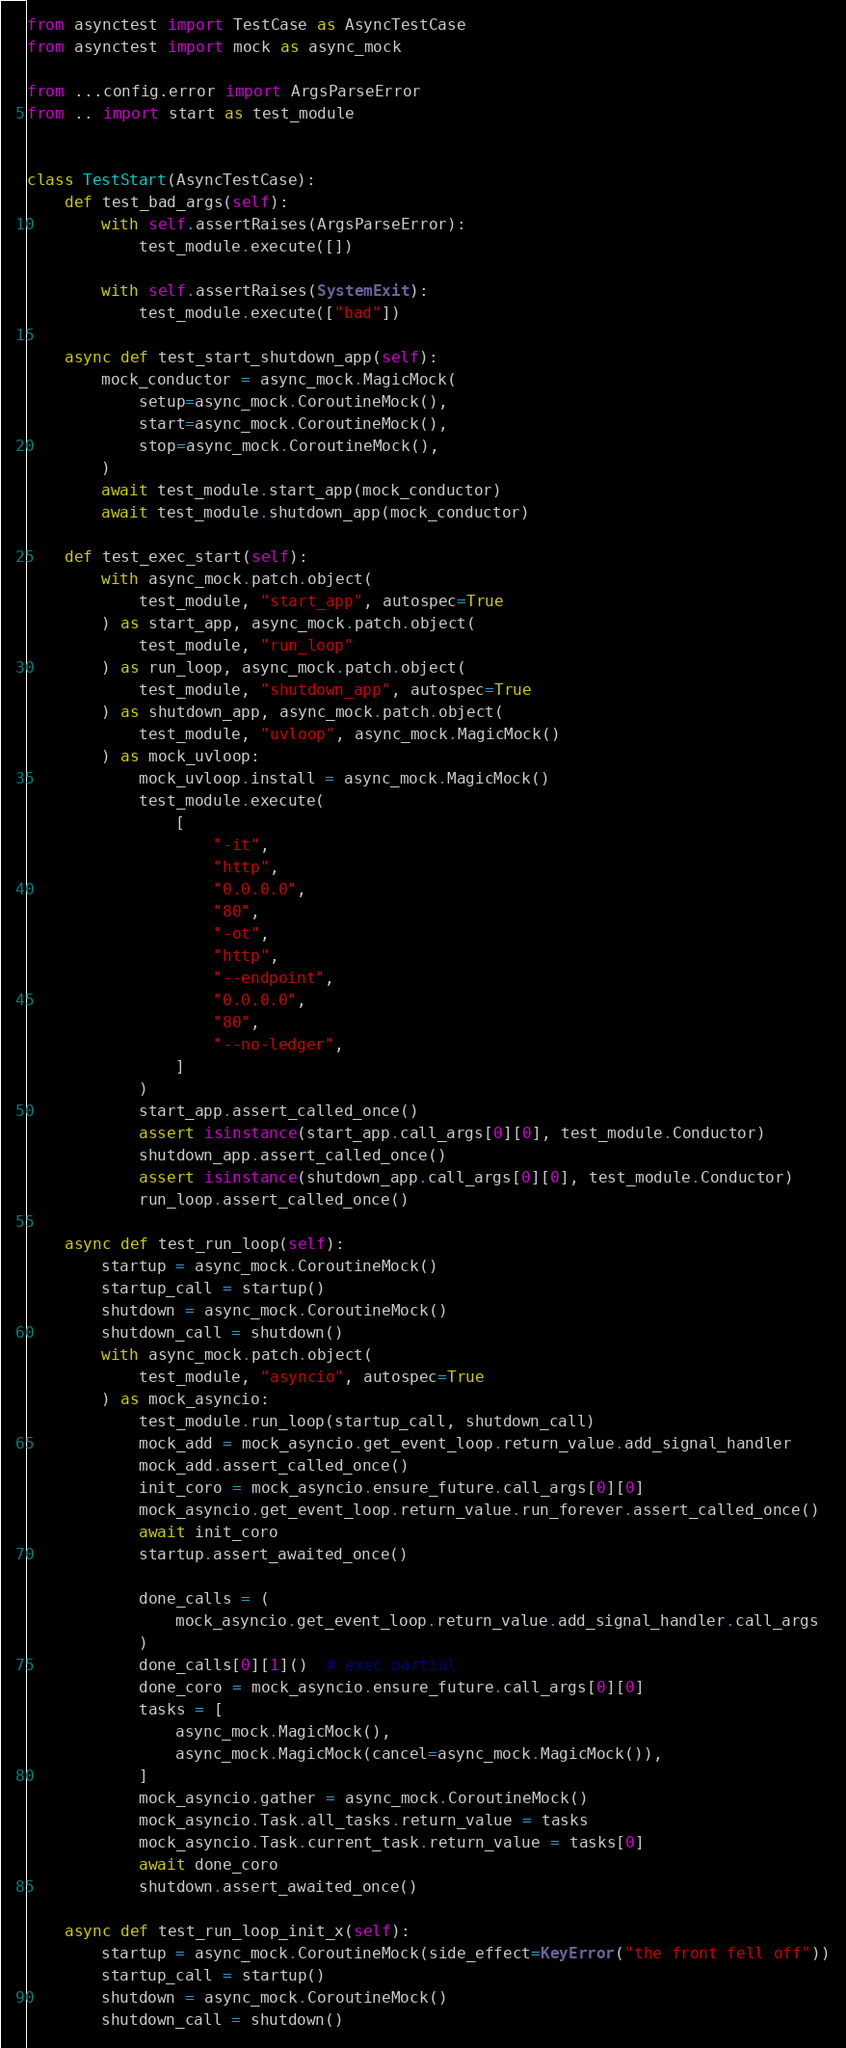Convert code to text. <code><loc_0><loc_0><loc_500><loc_500><_Python_>from asynctest import TestCase as AsyncTestCase
from asynctest import mock as async_mock

from ...config.error import ArgsParseError
from .. import start as test_module


class TestStart(AsyncTestCase):
    def test_bad_args(self):
        with self.assertRaises(ArgsParseError):
            test_module.execute([])

        with self.assertRaises(SystemExit):
            test_module.execute(["bad"])

    async def test_start_shutdown_app(self):
        mock_conductor = async_mock.MagicMock(
            setup=async_mock.CoroutineMock(),
            start=async_mock.CoroutineMock(),
            stop=async_mock.CoroutineMock(),
        )
        await test_module.start_app(mock_conductor)
        await test_module.shutdown_app(mock_conductor)

    def test_exec_start(self):
        with async_mock.patch.object(
            test_module, "start_app", autospec=True
        ) as start_app, async_mock.patch.object(
            test_module, "run_loop"
        ) as run_loop, async_mock.patch.object(
            test_module, "shutdown_app", autospec=True
        ) as shutdown_app, async_mock.patch.object(
            test_module, "uvloop", async_mock.MagicMock()
        ) as mock_uvloop:
            mock_uvloop.install = async_mock.MagicMock()
            test_module.execute(
                [
                    "-it",
                    "http",
                    "0.0.0.0",
                    "80",
                    "-ot",
                    "http",
                    "--endpoint",
                    "0.0.0.0",
                    "80",
                    "--no-ledger",
                ]
            )
            start_app.assert_called_once()
            assert isinstance(start_app.call_args[0][0], test_module.Conductor)
            shutdown_app.assert_called_once()
            assert isinstance(shutdown_app.call_args[0][0], test_module.Conductor)
            run_loop.assert_called_once()

    async def test_run_loop(self):
        startup = async_mock.CoroutineMock()
        startup_call = startup()
        shutdown = async_mock.CoroutineMock()
        shutdown_call = shutdown()
        with async_mock.patch.object(
            test_module, "asyncio", autospec=True
        ) as mock_asyncio:
            test_module.run_loop(startup_call, shutdown_call)
            mock_add = mock_asyncio.get_event_loop.return_value.add_signal_handler
            mock_add.assert_called_once()
            init_coro = mock_asyncio.ensure_future.call_args[0][0]
            mock_asyncio.get_event_loop.return_value.run_forever.assert_called_once()
            await init_coro
            startup.assert_awaited_once()

            done_calls = (
                mock_asyncio.get_event_loop.return_value.add_signal_handler.call_args
            )
            done_calls[0][1]()  # exec partial
            done_coro = mock_asyncio.ensure_future.call_args[0][0]
            tasks = [
                async_mock.MagicMock(),
                async_mock.MagicMock(cancel=async_mock.MagicMock()),
            ]
            mock_asyncio.gather = async_mock.CoroutineMock()
            mock_asyncio.Task.all_tasks.return_value = tasks
            mock_asyncio.Task.current_task.return_value = tasks[0]
            await done_coro
            shutdown.assert_awaited_once()

    async def test_run_loop_init_x(self):
        startup = async_mock.CoroutineMock(side_effect=KeyError("the front fell off"))
        startup_call = startup()
        shutdown = async_mock.CoroutineMock()
        shutdown_call = shutdown()</code> 